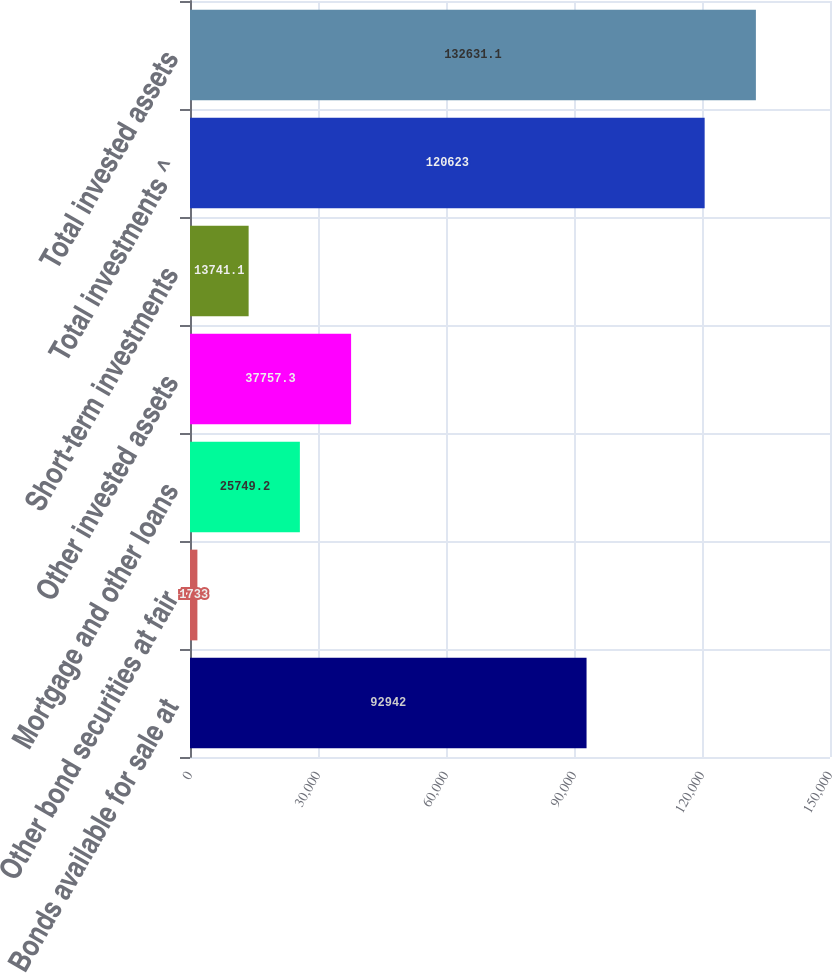<chart> <loc_0><loc_0><loc_500><loc_500><bar_chart><fcel>Bonds available for sale at<fcel>Other bond securities at fair<fcel>Mortgage and other loans<fcel>Other invested assets<fcel>Short-term investments<fcel>Total investments ^<fcel>Total invested assets<nl><fcel>92942<fcel>1733<fcel>25749.2<fcel>37757.3<fcel>13741.1<fcel>120623<fcel>132631<nl></chart> 